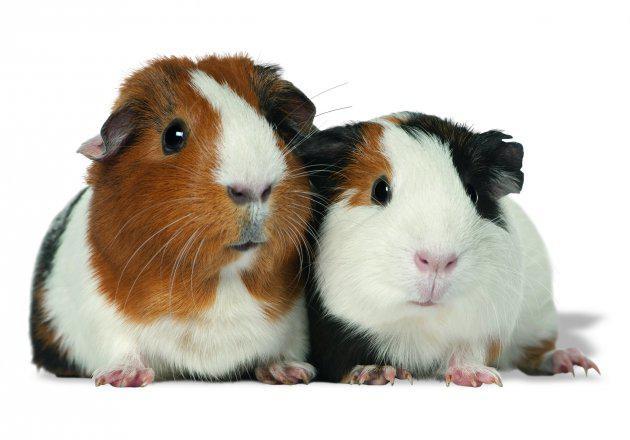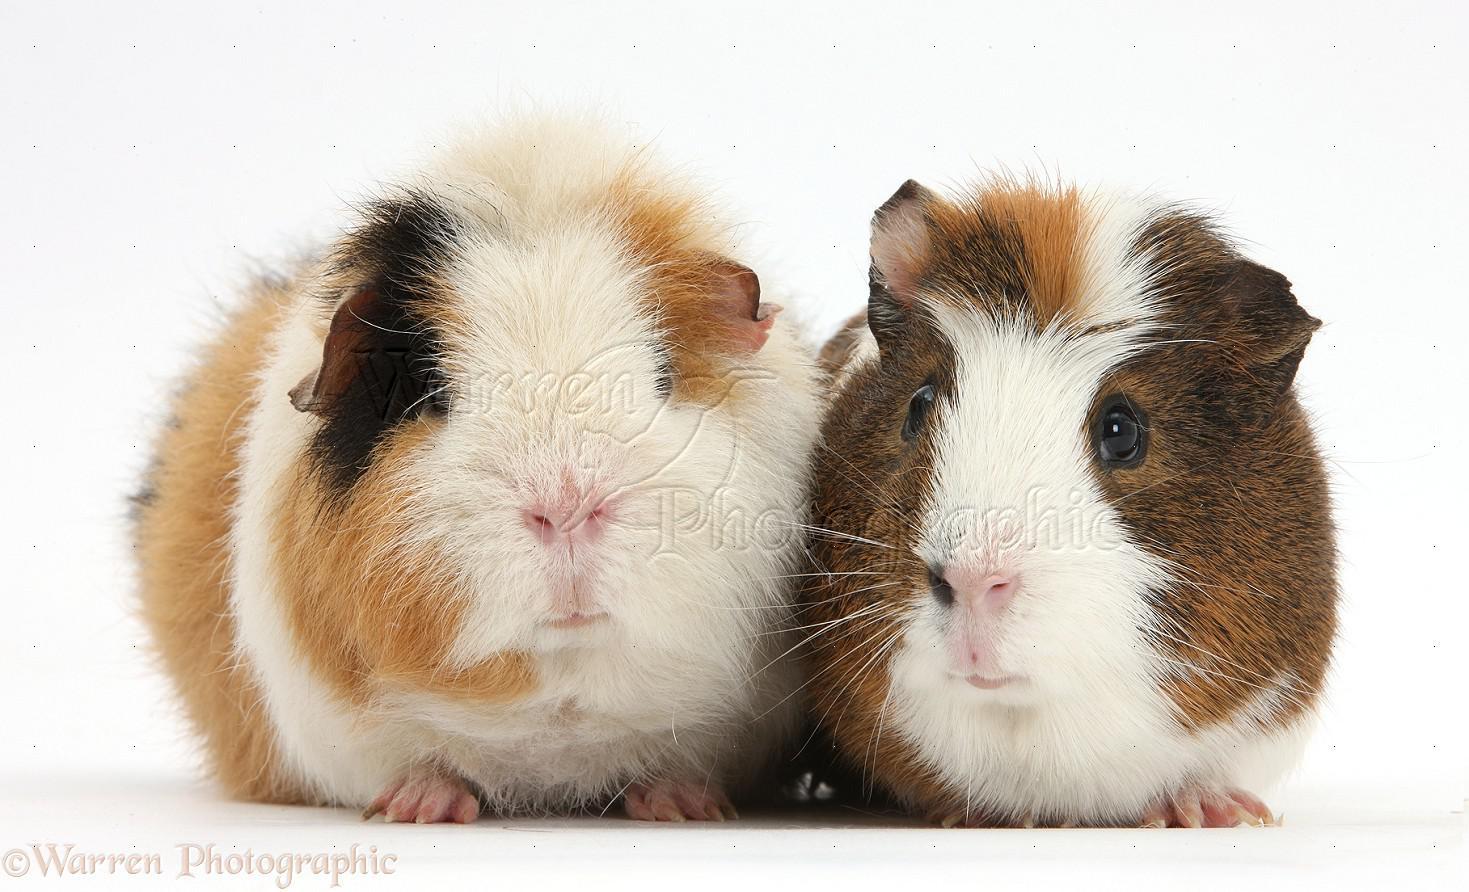The first image is the image on the left, the second image is the image on the right. Analyze the images presented: Is the assertion "A rabbit is posing with the rodent in one of the images." valid? Answer yes or no. No. The first image is the image on the left, the second image is the image on the right. Analyze the images presented: Is the assertion "One image shows a multicolored guinea pig next to a different pet with longer ears." valid? Answer yes or no. No. 